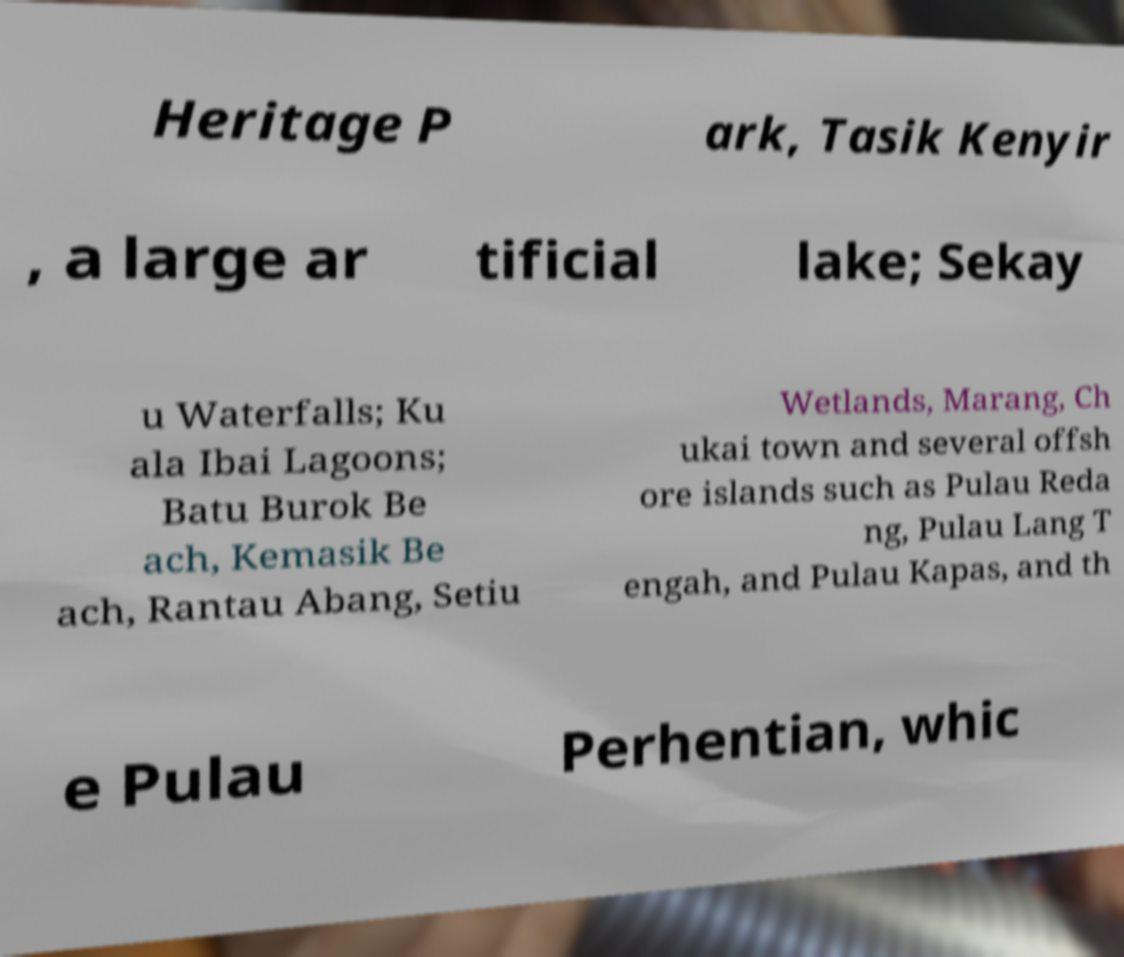I need the written content from this picture converted into text. Can you do that? Heritage P ark, Tasik Kenyir , a large ar tificial lake; Sekay u Waterfalls; Ku ala Ibai Lagoons; Batu Burok Be ach, Kemasik Be ach, Rantau Abang, Setiu Wetlands, Marang, Ch ukai town and several offsh ore islands such as Pulau Reda ng, Pulau Lang T engah, and Pulau Kapas, and th e Pulau Perhentian, whic 